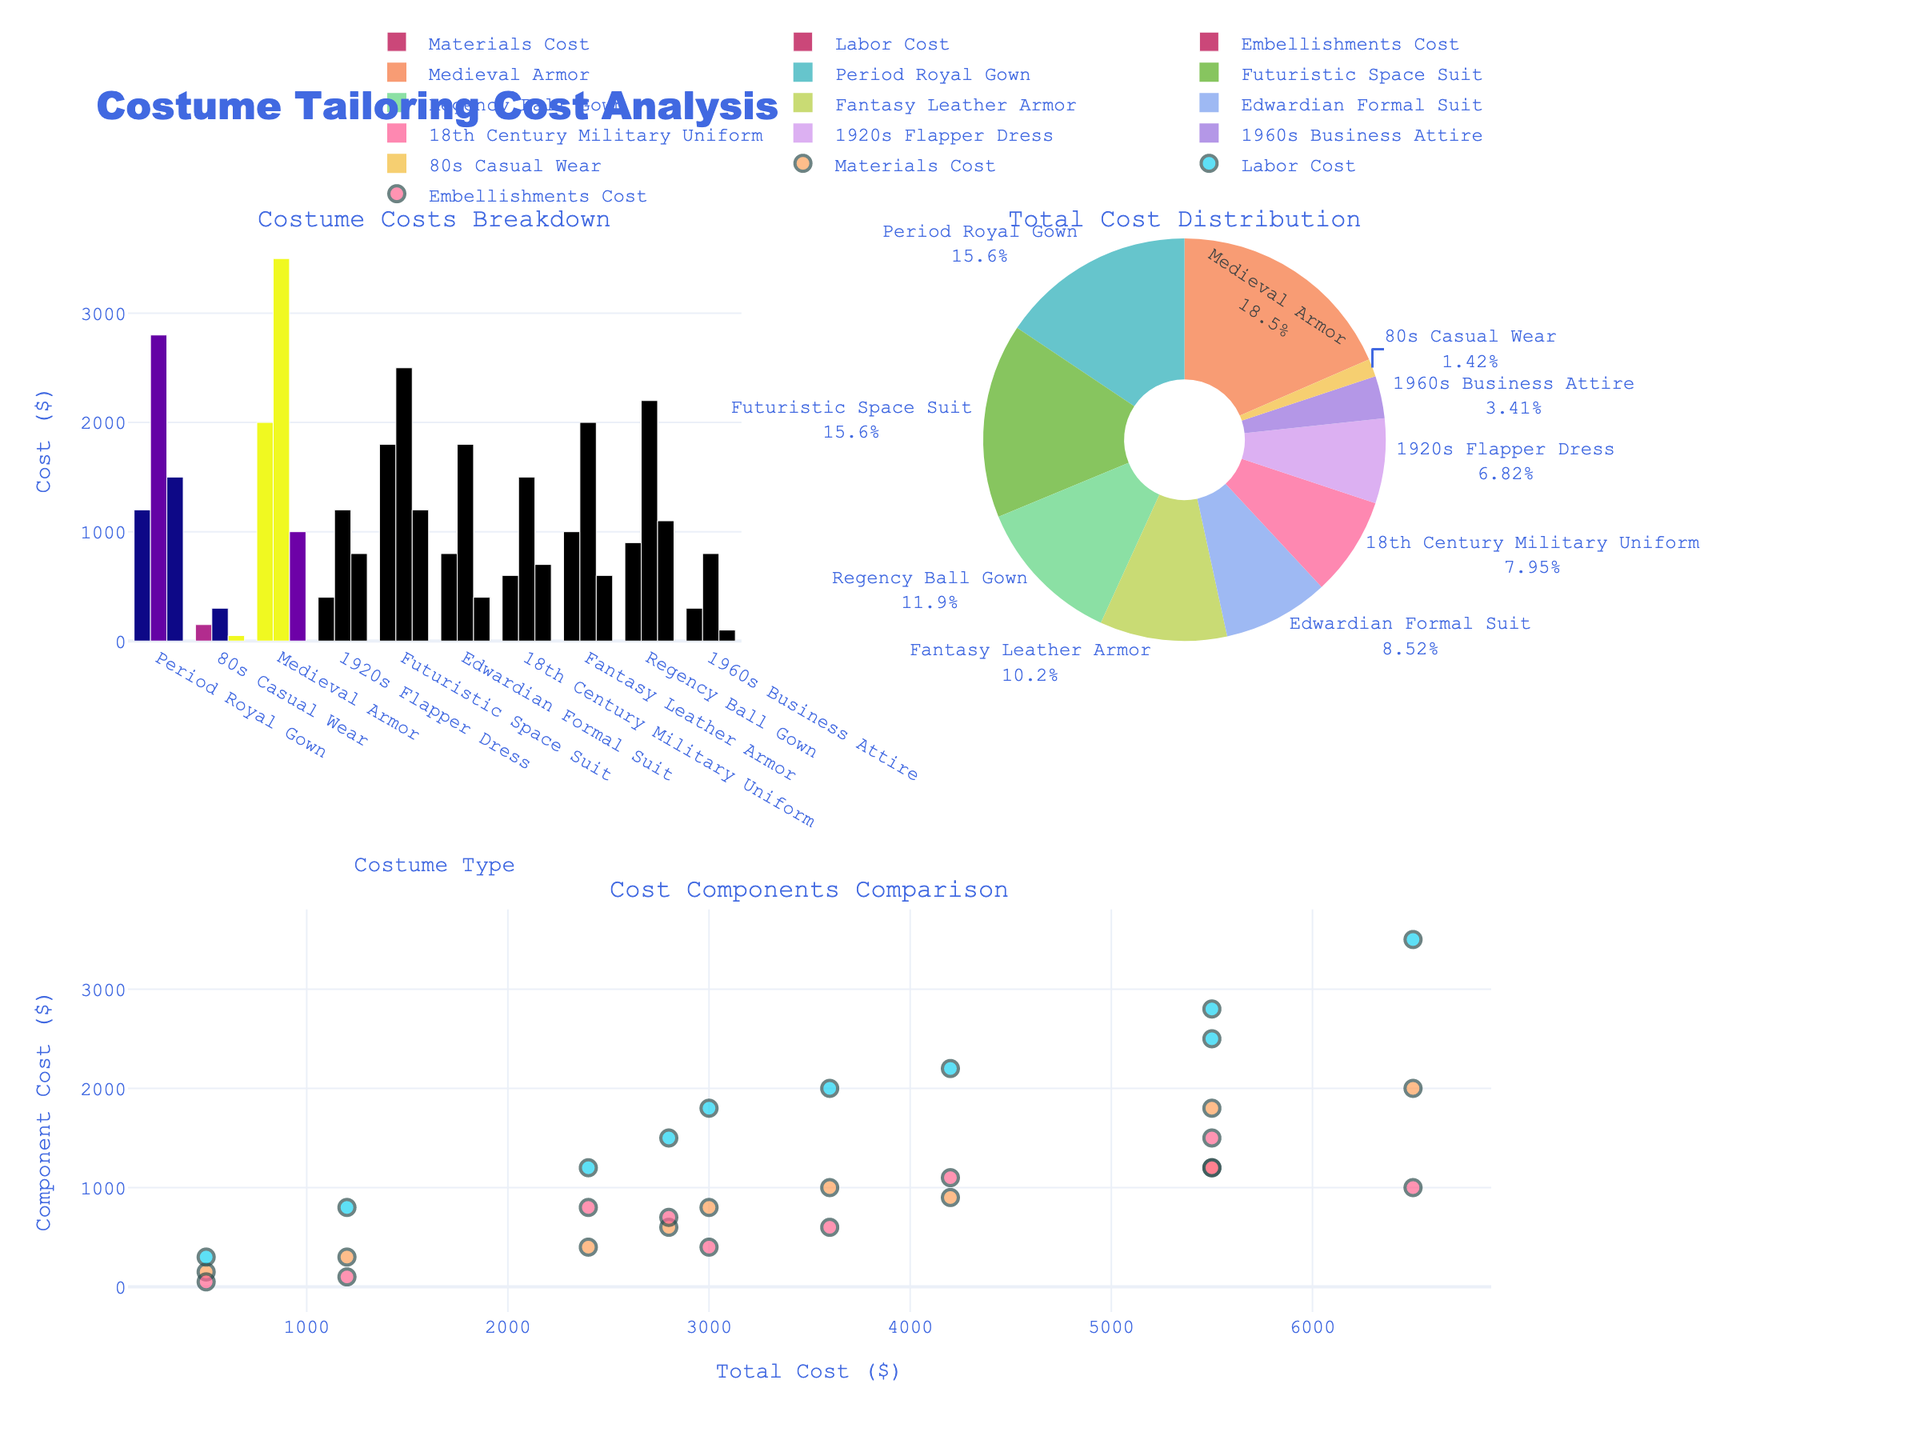What is the title of the figure? The title of the figure is displayed at the top of the plot. It reads "Costume Tailoring Cost Analysis".
Answer: Costume Tailoring Cost Analysis Which costume type has the highest total cost in the pie chart? By examining the pie chart, "Game of Thrones" with the Medieval Armor costume type occupies the largest slice, indicating it has the highest total cost.
Answer: Game of Thrones What are the three cost components shown in the bar chart? The bar chart has bars representing three cost components for each costume type: Materials Cost, Labor Cost, and Embellishments Cost.
Answer: Materials Cost, Labor Cost, Embellishments Cost Which two costume types have equal total costs in the pie chart? The pie chart shows that "The Crown" and "Star Wars" each have a total cost of $5500, which makes them equal.
Answer: The Crown and Star Wars How does the Labor Cost of the Period Royal Gown compare to its Materials Cost? On the bar chart, the bar representing the Labor Cost for the Period Royal Gown is significantly taller than the bar representing its Materials Cost, indicating the Labor Cost is higher.
Answer: Labor Cost is higher What is the difference in total cost between the Edwardian Formal Suit and the 80s Casual Wear? The total costs are $3000 for the Edwardian Formal Suit ("Downton Abbey") and $500 for the 80s Casual Wear ("Stranger Things"). Subtracting these gives: $3000 - $500 = $2500.
Answer: $2500 Which cost component shows the most variation in the scatter plot? In the scatter plot, the Labor Cost markers are spread over a wider range on the y-axis compared to Materials Cost and Embellishments Cost, indicating the most variation.
Answer: Labor Cost How much of the total cost of the 1920s Flapper Dress is due to Embellishments? Referring to the bar chart, the Embellishments Cost for the 1920s Flapper Dress is given as $800.
Answer: $800 Which costume type has the lowest Materials Cost in the bar chart? The bar chart shows the 80s Casual Wear has the lowest Materials Cost, marked by the shortest bar.
Answer: 80s Casual Wear What are the axis labels for the scatter plot? The scatter plot's x-axis is labeled "Total Cost ($)" and the y-axis is labeled "Component Cost ($)".
Answer: Total Cost ($), Component Cost ($) 